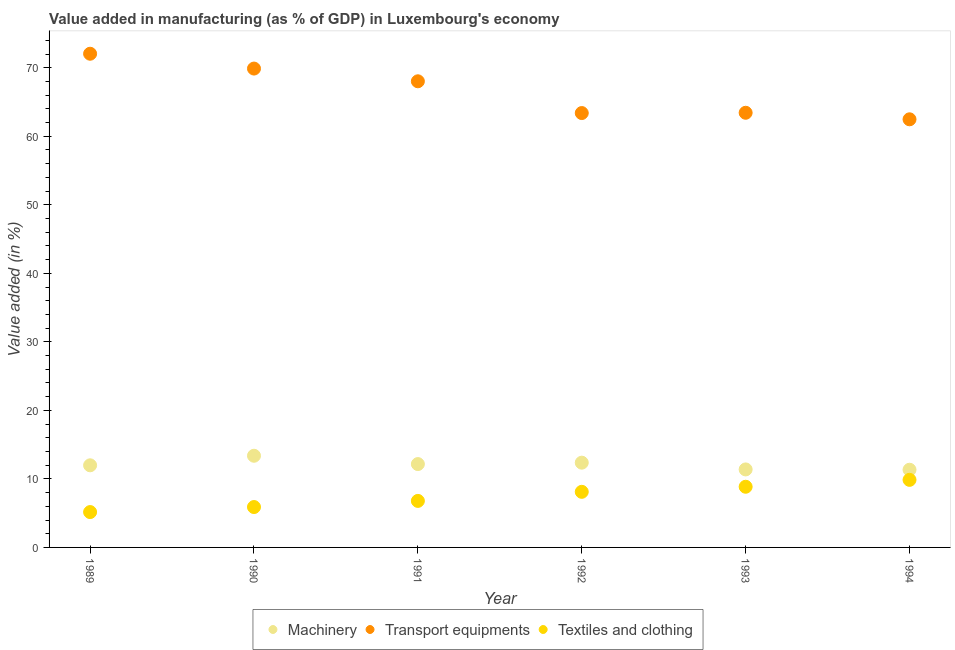How many different coloured dotlines are there?
Offer a terse response. 3. What is the value added in manufacturing machinery in 1994?
Keep it short and to the point. 11.34. Across all years, what is the maximum value added in manufacturing textile and clothing?
Give a very brief answer. 9.86. Across all years, what is the minimum value added in manufacturing textile and clothing?
Offer a very short reply. 5.16. In which year was the value added in manufacturing machinery minimum?
Your response must be concise. 1994. What is the total value added in manufacturing transport equipments in the graph?
Your response must be concise. 399.24. What is the difference between the value added in manufacturing transport equipments in 1990 and that in 1992?
Provide a short and direct response. 6.49. What is the difference between the value added in manufacturing transport equipments in 1994 and the value added in manufacturing textile and clothing in 1993?
Provide a short and direct response. 53.62. What is the average value added in manufacturing machinery per year?
Keep it short and to the point. 12.1. In the year 1991, what is the difference between the value added in manufacturing transport equipments and value added in manufacturing machinery?
Your response must be concise. 55.86. In how many years, is the value added in manufacturing machinery greater than 66 %?
Provide a short and direct response. 0. What is the ratio of the value added in manufacturing transport equipments in 1991 to that in 1994?
Ensure brevity in your answer.  1.09. Is the value added in manufacturing transport equipments in 1989 less than that in 1993?
Provide a short and direct response. No. Is the difference between the value added in manufacturing machinery in 1989 and 1993 greater than the difference between the value added in manufacturing textile and clothing in 1989 and 1993?
Give a very brief answer. Yes. What is the difference between the highest and the second highest value added in manufacturing machinery?
Ensure brevity in your answer.  1.01. What is the difference between the highest and the lowest value added in manufacturing textile and clothing?
Keep it short and to the point. 4.7. Is the sum of the value added in manufacturing textile and clothing in 1989 and 1992 greater than the maximum value added in manufacturing machinery across all years?
Keep it short and to the point. No. Is it the case that in every year, the sum of the value added in manufacturing machinery and value added in manufacturing transport equipments is greater than the value added in manufacturing textile and clothing?
Keep it short and to the point. Yes. How are the legend labels stacked?
Ensure brevity in your answer.  Horizontal. What is the title of the graph?
Your answer should be compact. Value added in manufacturing (as % of GDP) in Luxembourg's economy. What is the label or title of the X-axis?
Provide a succinct answer. Year. What is the label or title of the Y-axis?
Your response must be concise. Value added (in %). What is the Value added (in %) of Machinery in 1989?
Your response must be concise. 11.98. What is the Value added (in %) of Transport equipments in 1989?
Keep it short and to the point. 72.04. What is the Value added (in %) in Textiles and clothing in 1989?
Provide a succinct answer. 5.16. What is the Value added (in %) in Machinery in 1990?
Your answer should be compact. 13.38. What is the Value added (in %) of Transport equipments in 1990?
Provide a succinct answer. 69.88. What is the Value added (in %) in Textiles and clothing in 1990?
Keep it short and to the point. 5.89. What is the Value added (in %) of Machinery in 1991?
Your answer should be compact. 12.16. What is the Value added (in %) in Transport equipments in 1991?
Provide a succinct answer. 68.02. What is the Value added (in %) of Textiles and clothing in 1991?
Give a very brief answer. 6.79. What is the Value added (in %) in Machinery in 1992?
Provide a short and direct response. 12.37. What is the Value added (in %) of Transport equipments in 1992?
Keep it short and to the point. 63.39. What is the Value added (in %) in Textiles and clothing in 1992?
Your answer should be very brief. 8.11. What is the Value added (in %) of Machinery in 1993?
Your answer should be very brief. 11.38. What is the Value added (in %) of Transport equipments in 1993?
Ensure brevity in your answer.  63.43. What is the Value added (in %) of Textiles and clothing in 1993?
Make the answer very short. 8.85. What is the Value added (in %) of Machinery in 1994?
Provide a short and direct response. 11.34. What is the Value added (in %) of Transport equipments in 1994?
Provide a short and direct response. 62.48. What is the Value added (in %) in Textiles and clothing in 1994?
Make the answer very short. 9.86. Across all years, what is the maximum Value added (in %) of Machinery?
Provide a short and direct response. 13.38. Across all years, what is the maximum Value added (in %) in Transport equipments?
Give a very brief answer. 72.04. Across all years, what is the maximum Value added (in %) in Textiles and clothing?
Offer a very short reply. 9.86. Across all years, what is the minimum Value added (in %) of Machinery?
Provide a short and direct response. 11.34. Across all years, what is the minimum Value added (in %) of Transport equipments?
Your response must be concise. 62.48. Across all years, what is the minimum Value added (in %) in Textiles and clothing?
Keep it short and to the point. 5.16. What is the total Value added (in %) in Machinery in the graph?
Provide a succinct answer. 72.61. What is the total Value added (in %) in Transport equipments in the graph?
Your response must be concise. 399.24. What is the total Value added (in %) of Textiles and clothing in the graph?
Ensure brevity in your answer.  44.67. What is the difference between the Value added (in %) in Machinery in 1989 and that in 1990?
Make the answer very short. -1.4. What is the difference between the Value added (in %) of Transport equipments in 1989 and that in 1990?
Make the answer very short. 2.16. What is the difference between the Value added (in %) in Textiles and clothing in 1989 and that in 1990?
Ensure brevity in your answer.  -0.73. What is the difference between the Value added (in %) of Machinery in 1989 and that in 1991?
Ensure brevity in your answer.  -0.18. What is the difference between the Value added (in %) in Transport equipments in 1989 and that in 1991?
Offer a terse response. 4.02. What is the difference between the Value added (in %) in Textiles and clothing in 1989 and that in 1991?
Give a very brief answer. -1.63. What is the difference between the Value added (in %) in Machinery in 1989 and that in 1992?
Offer a very short reply. -0.39. What is the difference between the Value added (in %) in Transport equipments in 1989 and that in 1992?
Give a very brief answer. 8.66. What is the difference between the Value added (in %) of Textiles and clothing in 1989 and that in 1992?
Offer a very short reply. -2.95. What is the difference between the Value added (in %) of Machinery in 1989 and that in 1993?
Keep it short and to the point. 0.6. What is the difference between the Value added (in %) of Transport equipments in 1989 and that in 1993?
Give a very brief answer. 8.61. What is the difference between the Value added (in %) in Textiles and clothing in 1989 and that in 1993?
Your answer should be very brief. -3.69. What is the difference between the Value added (in %) in Machinery in 1989 and that in 1994?
Provide a short and direct response. 0.65. What is the difference between the Value added (in %) of Transport equipments in 1989 and that in 1994?
Offer a terse response. 9.57. What is the difference between the Value added (in %) in Textiles and clothing in 1989 and that in 1994?
Offer a terse response. -4.7. What is the difference between the Value added (in %) of Machinery in 1990 and that in 1991?
Offer a terse response. 1.21. What is the difference between the Value added (in %) in Transport equipments in 1990 and that in 1991?
Offer a terse response. 1.86. What is the difference between the Value added (in %) of Textiles and clothing in 1990 and that in 1991?
Offer a terse response. -0.89. What is the difference between the Value added (in %) in Machinery in 1990 and that in 1992?
Provide a short and direct response. 1.01. What is the difference between the Value added (in %) of Transport equipments in 1990 and that in 1992?
Ensure brevity in your answer.  6.49. What is the difference between the Value added (in %) in Textiles and clothing in 1990 and that in 1992?
Your answer should be very brief. -2.22. What is the difference between the Value added (in %) of Machinery in 1990 and that in 1993?
Offer a very short reply. 2. What is the difference between the Value added (in %) of Transport equipments in 1990 and that in 1993?
Offer a terse response. 6.45. What is the difference between the Value added (in %) of Textiles and clothing in 1990 and that in 1993?
Your answer should be compact. -2.96. What is the difference between the Value added (in %) in Machinery in 1990 and that in 1994?
Your answer should be compact. 2.04. What is the difference between the Value added (in %) of Transport equipments in 1990 and that in 1994?
Your answer should be very brief. 7.4. What is the difference between the Value added (in %) in Textiles and clothing in 1990 and that in 1994?
Ensure brevity in your answer.  -3.97. What is the difference between the Value added (in %) in Machinery in 1991 and that in 1992?
Offer a terse response. -0.2. What is the difference between the Value added (in %) of Transport equipments in 1991 and that in 1992?
Your answer should be very brief. 4.64. What is the difference between the Value added (in %) in Textiles and clothing in 1991 and that in 1992?
Give a very brief answer. -1.33. What is the difference between the Value added (in %) in Machinery in 1991 and that in 1993?
Your response must be concise. 0.78. What is the difference between the Value added (in %) of Transport equipments in 1991 and that in 1993?
Ensure brevity in your answer.  4.59. What is the difference between the Value added (in %) in Textiles and clothing in 1991 and that in 1993?
Keep it short and to the point. -2.07. What is the difference between the Value added (in %) in Machinery in 1991 and that in 1994?
Keep it short and to the point. 0.83. What is the difference between the Value added (in %) in Transport equipments in 1991 and that in 1994?
Give a very brief answer. 5.55. What is the difference between the Value added (in %) in Textiles and clothing in 1991 and that in 1994?
Ensure brevity in your answer.  -3.07. What is the difference between the Value added (in %) in Machinery in 1992 and that in 1993?
Provide a succinct answer. 0.99. What is the difference between the Value added (in %) of Transport equipments in 1992 and that in 1993?
Ensure brevity in your answer.  -0.04. What is the difference between the Value added (in %) of Textiles and clothing in 1992 and that in 1993?
Your response must be concise. -0.74. What is the difference between the Value added (in %) in Machinery in 1992 and that in 1994?
Give a very brief answer. 1.03. What is the difference between the Value added (in %) in Transport equipments in 1992 and that in 1994?
Ensure brevity in your answer.  0.91. What is the difference between the Value added (in %) of Textiles and clothing in 1992 and that in 1994?
Give a very brief answer. -1.75. What is the difference between the Value added (in %) of Machinery in 1993 and that in 1994?
Offer a terse response. 0.05. What is the difference between the Value added (in %) of Transport equipments in 1993 and that in 1994?
Give a very brief answer. 0.95. What is the difference between the Value added (in %) in Textiles and clothing in 1993 and that in 1994?
Provide a succinct answer. -1.01. What is the difference between the Value added (in %) of Machinery in 1989 and the Value added (in %) of Transport equipments in 1990?
Your answer should be very brief. -57.9. What is the difference between the Value added (in %) in Machinery in 1989 and the Value added (in %) in Textiles and clothing in 1990?
Your answer should be compact. 6.09. What is the difference between the Value added (in %) of Transport equipments in 1989 and the Value added (in %) of Textiles and clothing in 1990?
Your response must be concise. 66.15. What is the difference between the Value added (in %) of Machinery in 1989 and the Value added (in %) of Transport equipments in 1991?
Your answer should be very brief. -56.04. What is the difference between the Value added (in %) in Machinery in 1989 and the Value added (in %) in Textiles and clothing in 1991?
Make the answer very short. 5.2. What is the difference between the Value added (in %) of Transport equipments in 1989 and the Value added (in %) of Textiles and clothing in 1991?
Make the answer very short. 65.26. What is the difference between the Value added (in %) of Machinery in 1989 and the Value added (in %) of Transport equipments in 1992?
Your answer should be very brief. -51.4. What is the difference between the Value added (in %) of Machinery in 1989 and the Value added (in %) of Textiles and clothing in 1992?
Offer a very short reply. 3.87. What is the difference between the Value added (in %) of Transport equipments in 1989 and the Value added (in %) of Textiles and clothing in 1992?
Offer a terse response. 63.93. What is the difference between the Value added (in %) in Machinery in 1989 and the Value added (in %) in Transport equipments in 1993?
Provide a succinct answer. -51.45. What is the difference between the Value added (in %) of Machinery in 1989 and the Value added (in %) of Textiles and clothing in 1993?
Provide a succinct answer. 3.13. What is the difference between the Value added (in %) in Transport equipments in 1989 and the Value added (in %) in Textiles and clothing in 1993?
Offer a very short reply. 63.19. What is the difference between the Value added (in %) in Machinery in 1989 and the Value added (in %) in Transport equipments in 1994?
Your answer should be compact. -50.49. What is the difference between the Value added (in %) of Machinery in 1989 and the Value added (in %) of Textiles and clothing in 1994?
Your answer should be very brief. 2.12. What is the difference between the Value added (in %) in Transport equipments in 1989 and the Value added (in %) in Textiles and clothing in 1994?
Make the answer very short. 62.18. What is the difference between the Value added (in %) of Machinery in 1990 and the Value added (in %) of Transport equipments in 1991?
Give a very brief answer. -54.65. What is the difference between the Value added (in %) in Machinery in 1990 and the Value added (in %) in Textiles and clothing in 1991?
Your response must be concise. 6.59. What is the difference between the Value added (in %) of Transport equipments in 1990 and the Value added (in %) of Textiles and clothing in 1991?
Your answer should be compact. 63.09. What is the difference between the Value added (in %) in Machinery in 1990 and the Value added (in %) in Transport equipments in 1992?
Offer a very short reply. -50.01. What is the difference between the Value added (in %) in Machinery in 1990 and the Value added (in %) in Textiles and clothing in 1992?
Provide a short and direct response. 5.26. What is the difference between the Value added (in %) in Transport equipments in 1990 and the Value added (in %) in Textiles and clothing in 1992?
Offer a terse response. 61.77. What is the difference between the Value added (in %) of Machinery in 1990 and the Value added (in %) of Transport equipments in 1993?
Provide a short and direct response. -50.05. What is the difference between the Value added (in %) in Machinery in 1990 and the Value added (in %) in Textiles and clothing in 1993?
Your response must be concise. 4.52. What is the difference between the Value added (in %) of Transport equipments in 1990 and the Value added (in %) of Textiles and clothing in 1993?
Your answer should be compact. 61.03. What is the difference between the Value added (in %) in Machinery in 1990 and the Value added (in %) in Transport equipments in 1994?
Make the answer very short. -49.1. What is the difference between the Value added (in %) of Machinery in 1990 and the Value added (in %) of Textiles and clothing in 1994?
Keep it short and to the point. 3.52. What is the difference between the Value added (in %) in Transport equipments in 1990 and the Value added (in %) in Textiles and clothing in 1994?
Ensure brevity in your answer.  60.02. What is the difference between the Value added (in %) of Machinery in 1991 and the Value added (in %) of Transport equipments in 1992?
Keep it short and to the point. -51.22. What is the difference between the Value added (in %) of Machinery in 1991 and the Value added (in %) of Textiles and clothing in 1992?
Keep it short and to the point. 4.05. What is the difference between the Value added (in %) in Transport equipments in 1991 and the Value added (in %) in Textiles and clothing in 1992?
Ensure brevity in your answer.  59.91. What is the difference between the Value added (in %) in Machinery in 1991 and the Value added (in %) in Transport equipments in 1993?
Your answer should be very brief. -51.27. What is the difference between the Value added (in %) of Machinery in 1991 and the Value added (in %) of Textiles and clothing in 1993?
Your response must be concise. 3.31. What is the difference between the Value added (in %) in Transport equipments in 1991 and the Value added (in %) in Textiles and clothing in 1993?
Your answer should be compact. 59.17. What is the difference between the Value added (in %) in Machinery in 1991 and the Value added (in %) in Transport equipments in 1994?
Your answer should be very brief. -50.31. What is the difference between the Value added (in %) in Machinery in 1991 and the Value added (in %) in Textiles and clothing in 1994?
Offer a very short reply. 2.3. What is the difference between the Value added (in %) in Transport equipments in 1991 and the Value added (in %) in Textiles and clothing in 1994?
Your response must be concise. 58.16. What is the difference between the Value added (in %) of Machinery in 1992 and the Value added (in %) of Transport equipments in 1993?
Your response must be concise. -51.06. What is the difference between the Value added (in %) in Machinery in 1992 and the Value added (in %) in Textiles and clothing in 1993?
Give a very brief answer. 3.51. What is the difference between the Value added (in %) in Transport equipments in 1992 and the Value added (in %) in Textiles and clothing in 1993?
Keep it short and to the point. 54.53. What is the difference between the Value added (in %) of Machinery in 1992 and the Value added (in %) of Transport equipments in 1994?
Your answer should be very brief. -50.11. What is the difference between the Value added (in %) of Machinery in 1992 and the Value added (in %) of Textiles and clothing in 1994?
Ensure brevity in your answer.  2.51. What is the difference between the Value added (in %) in Transport equipments in 1992 and the Value added (in %) in Textiles and clothing in 1994?
Keep it short and to the point. 53.53. What is the difference between the Value added (in %) in Machinery in 1993 and the Value added (in %) in Transport equipments in 1994?
Give a very brief answer. -51.09. What is the difference between the Value added (in %) in Machinery in 1993 and the Value added (in %) in Textiles and clothing in 1994?
Offer a very short reply. 1.52. What is the difference between the Value added (in %) of Transport equipments in 1993 and the Value added (in %) of Textiles and clothing in 1994?
Offer a terse response. 53.57. What is the average Value added (in %) of Machinery per year?
Offer a very short reply. 12.1. What is the average Value added (in %) in Transport equipments per year?
Keep it short and to the point. 66.54. What is the average Value added (in %) of Textiles and clothing per year?
Offer a very short reply. 7.44. In the year 1989, what is the difference between the Value added (in %) of Machinery and Value added (in %) of Transport equipments?
Provide a short and direct response. -60.06. In the year 1989, what is the difference between the Value added (in %) of Machinery and Value added (in %) of Textiles and clothing?
Your answer should be compact. 6.82. In the year 1989, what is the difference between the Value added (in %) in Transport equipments and Value added (in %) in Textiles and clothing?
Your response must be concise. 66.88. In the year 1990, what is the difference between the Value added (in %) of Machinery and Value added (in %) of Transport equipments?
Provide a short and direct response. -56.5. In the year 1990, what is the difference between the Value added (in %) of Machinery and Value added (in %) of Textiles and clothing?
Give a very brief answer. 7.49. In the year 1990, what is the difference between the Value added (in %) of Transport equipments and Value added (in %) of Textiles and clothing?
Give a very brief answer. 63.99. In the year 1991, what is the difference between the Value added (in %) of Machinery and Value added (in %) of Transport equipments?
Keep it short and to the point. -55.86. In the year 1991, what is the difference between the Value added (in %) of Machinery and Value added (in %) of Textiles and clothing?
Keep it short and to the point. 5.38. In the year 1991, what is the difference between the Value added (in %) of Transport equipments and Value added (in %) of Textiles and clothing?
Your answer should be compact. 61.24. In the year 1992, what is the difference between the Value added (in %) of Machinery and Value added (in %) of Transport equipments?
Your answer should be very brief. -51.02. In the year 1992, what is the difference between the Value added (in %) of Machinery and Value added (in %) of Textiles and clothing?
Make the answer very short. 4.25. In the year 1992, what is the difference between the Value added (in %) of Transport equipments and Value added (in %) of Textiles and clothing?
Offer a terse response. 55.27. In the year 1993, what is the difference between the Value added (in %) in Machinery and Value added (in %) in Transport equipments?
Give a very brief answer. -52.05. In the year 1993, what is the difference between the Value added (in %) in Machinery and Value added (in %) in Textiles and clothing?
Your answer should be compact. 2.53. In the year 1993, what is the difference between the Value added (in %) in Transport equipments and Value added (in %) in Textiles and clothing?
Your response must be concise. 54.58. In the year 1994, what is the difference between the Value added (in %) in Machinery and Value added (in %) in Transport equipments?
Offer a terse response. -51.14. In the year 1994, what is the difference between the Value added (in %) of Machinery and Value added (in %) of Textiles and clothing?
Provide a succinct answer. 1.47. In the year 1994, what is the difference between the Value added (in %) of Transport equipments and Value added (in %) of Textiles and clothing?
Provide a succinct answer. 52.62. What is the ratio of the Value added (in %) in Machinery in 1989 to that in 1990?
Your answer should be compact. 0.9. What is the ratio of the Value added (in %) in Transport equipments in 1989 to that in 1990?
Your response must be concise. 1.03. What is the ratio of the Value added (in %) of Textiles and clothing in 1989 to that in 1990?
Offer a very short reply. 0.88. What is the ratio of the Value added (in %) of Machinery in 1989 to that in 1991?
Ensure brevity in your answer.  0.99. What is the ratio of the Value added (in %) in Transport equipments in 1989 to that in 1991?
Provide a short and direct response. 1.06. What is the ratio of the Value added (in %) of Textiles and clothing in 1989 to that in 1991?
Your answer should be compact. 0.76. What is the ratio of the Value added (in %) of Machinery in 1989 to that in 1992?
Ensure brevity in your answer.  0.97. What is the ratio of the Value added (in %) of Transport equipments in 1989 to that in 1992?
Make the answer very short. 1.14. What is the ratio of the Value added (in %) in Textiles and clothing in 1989 to that in 1992?
Your response must be concise. 0.64. What is the ratio of the Value added (in %) of Machinery in 1989 to that in 1993?
Make the answer very short. 1.05. What is the ratio of the Value added (in %) of Transport equipments in 1989 to that in 1993?
Your answer should be compact. 1.14. What is the ratio of the Value added (in %) of Textiles and clothing in 1989 to that in 1993?
Provide a short and direct response. 0.58. What is the ratio of the Value added (in %) in Machinery in 1989 to that in 1994?
Your response must be concise. 1.06. What is the ratio of the Value added (in %) of Transport equipments in 1989 to that in 1994?
Keep it short and to the point. 1.15. What is the ratio of the Value added (in %) of Textiles and clothing in 1989 to that in 1994?
Your answer should be very brief. 0.52. What is the ratio of the Value added (in %) in Machinery in 1990 to that in 1991?
Make the answer very short. 1.1. What is the ratio of the Value added (in %) in Transport equipments in 1990 to that in 1991?
Give a very brief answer. 1.03. What is the ratio of the Value added (in %) of Textiles and clothing in 1990 to that in 1991?
Your answer should be compact. 0.87. What is the ratio of the Value added (in %) in Machinery in 1990 to that in 1992?
Ensure brevity in your answer.  1.08. What is the ratio of the Value added (in %) of Transport equipments in 1990 to that in 1992?
Offer a very short reply. 1.1. What is the ratio of the Value added (in %) of Textiles and clothing in 1990 to that in 1992?
Make the answer very short. 0.73. What is the ratio of the Value added (in %) of Machinery in 1990 to that in 1993?
Make the answer very short. 1.18. What is the ratio of the Value added (in %) in Transport equipments in 1990 to that in 1993?
Provide a short and direct response. 1.1. What is the ratio of the Value added (in %) of Textiles and clothing in 1990 to that in 1993?
Offer a very short reply. 0.67. What is the ratio of the Value added (in %) in Machinery in 1990 to that in 1994?
Provide a short and direct response. 1.18. What is the ratio of the Value added (in %) of Transport equipments in 1990 to that in 1994?
Give a very brief answer. 1.12. What is the ratio of the Value added (in %) in Textiles and clothing in 1990 to that in 1994?
Offer a very short reply. 0.6. What is the ratio of the Value added (in %) of Machinery in 1991 to that in 1992?
Your response must be concise. 0.98. What is the ratio of the Value added (in %) in Transport equipments in 1991 to that in 1992?
Your answer should be very brief. 1.07. What is the ratio of the Value added (in %) in Textiles and clothing in 1991 to that in 1992?
Offer a terse response. 0.84. What is the ratio of the Value added (in %) in Machinery in 1991 to that in 1993?
Provide a succinct answer. 1.07. What is the ratio of the Value added (in %) in Transport equipments in 1991 to that in 1993?
Give a very brief answer. 1.07. What is the ratio of the Value added (in %) of Textiles and clothing in 1991 to that in 1993?
Make the answer very short. 0.77. What is the ratio of the Value added (in %) of Machinery in 1991 to that in 1994?
Ensure brevity in your answer.  1.07. What is the ratio of the Value added (in %) of Transport equipments in 1991 to that in 1994?
Provide a short and direct response. 1.09. What is the ratio of the Value added (in %) of Textiles and clothing in 1991 to that in 1994?
Make the answer very short. 0.69. What is the ratio of the Value added (in %) of Machinery in 1992 to that in 1993?
Offer a terse response. 1.09. What is the ratio of the Value added (in %) of Transport equipments in 1992 to that in 1993?
Offer a terse response. 1. What is the ratio of the Value added (in %) of Textiles and clothing in 1992 to that in 1993?
Your response must be concise. 0.92. What is the ratio of the Value added (in %) of Machinery in 1992 to that in 1994?
Keep it short and to the point. 1.09. What is the ratio of the Value added (in %) in Transport equipments in 1992 to that in 1994?
Give a very brief answer. 1.01. What is the ratio of the Value added (in %) in Textiles and clothing in 1992 to that in 1994?
Offer a terse response. 0.82. What is the ratio of the Value added (in %) in Transport equipments in 1993 to that in 1994?
Your answer should be very brief. 1.02. What is the ratio of the Value added (in %) of Textiles and clothing in 1993 to that in 1994?
Make the answer very short. 0.9. What is the difference between the highest and the second highest Value added (in %) in Transport equipments?
Your answer should be compact. 2.16. What is the difference between the highest and the lowest Value added (in %) in Machinery?
Your answer should be compact. 2.04. What is the difference between the highest and the lowest Value added (in %) of Transport equipments?
Offer a terse response. 9.57. What is the difference between the highest and the lowest Value added (in %) in Textiles and clothing?
Provide a succinct answer. 4.7. 